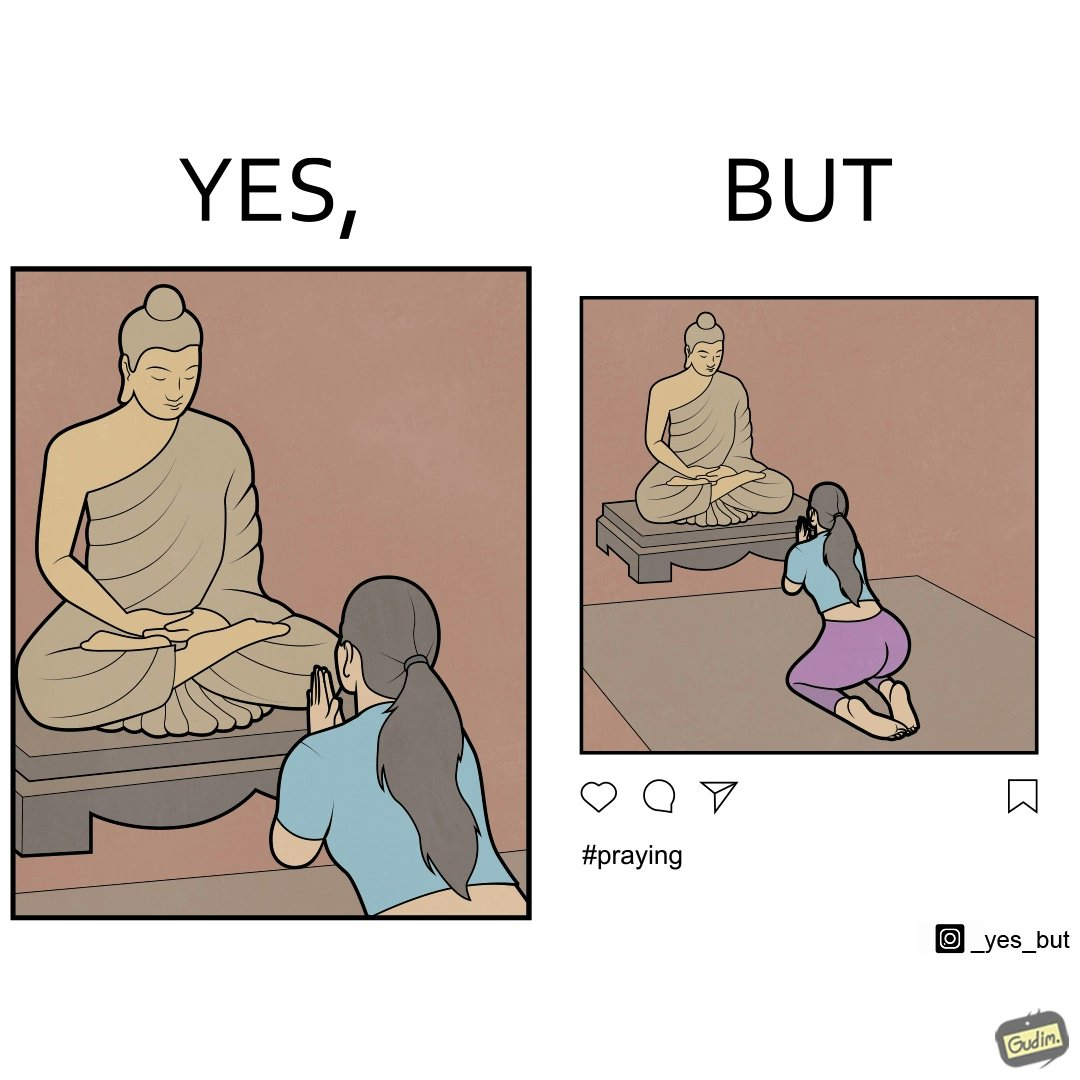Is this image satirical or non-satirical? Yes, this image is satirical. 